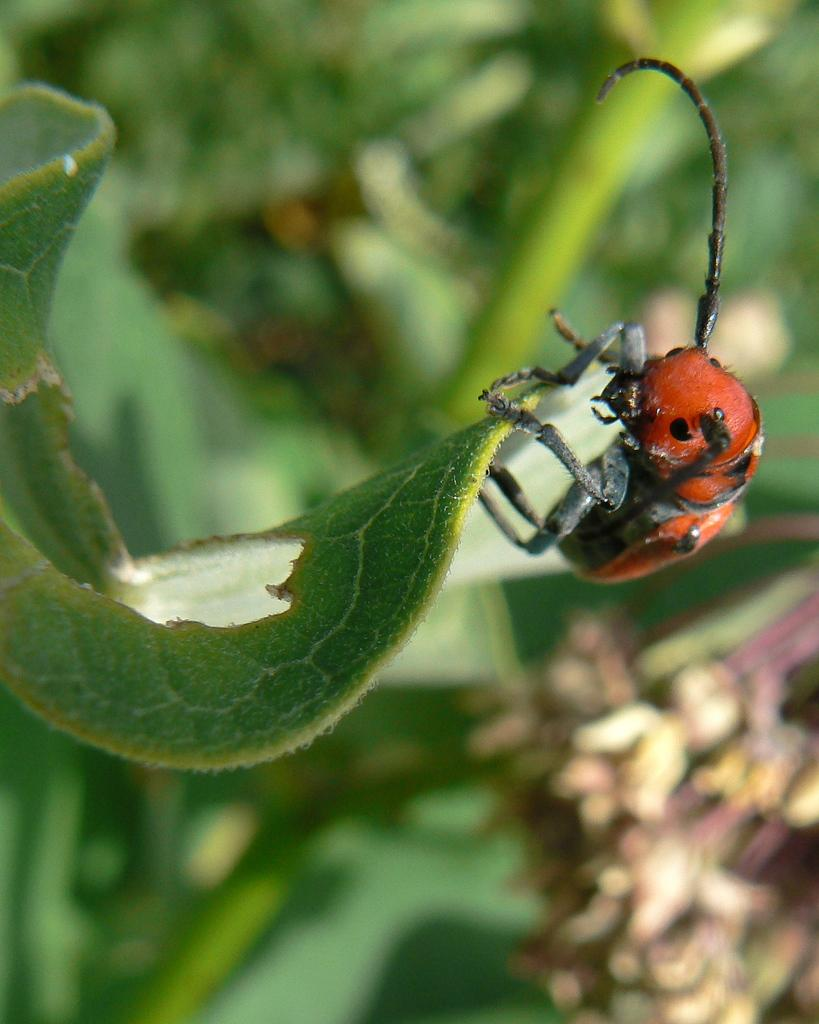What type of insect is present in the image? There is a ladybug in the image. What is the ladybug sitting on in the image? The ladybug is sitting on a leaf in the image. Can you describe the background of the image? The background of the image is blurry. What type of frame is surrounding the moon in the image? There is no moon present in the image, and therefore no frame surrounding it. 